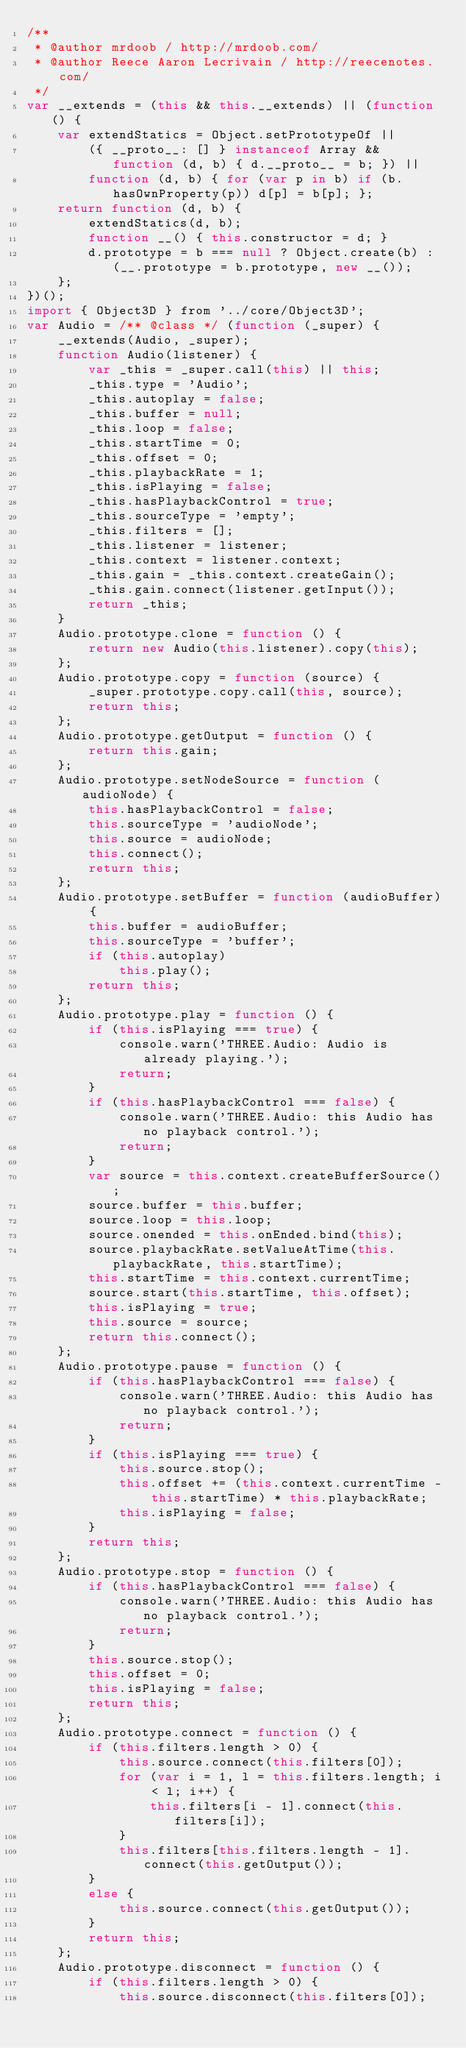Convert code to text. <code><loc_0><loc_0><loc_500><loc_500><_JavaScript_>/**
 * @author mrdoob / http://mrdoob.com/
 * @author Reece Aaron Lecrivain / http://reecenotes.com/
 */
var __extends = (this && this.__extends) || (function () {
    var extendStatics = Object.setPrototypeOf ||
        ({ __proto__: [] } instanceof Array && function (d, b) { d.__proto__ = b; }) ||
        function (d, b) { for (var p in b) if (b.hasOwnProperty(p)) d[p] = b[p]; };
    return function (d, b) {
        extendStatics(d, b);
        function __() { this.constructor = d; }
        d.prototype = b === null ? Object.create(b) : (__.prototype = b.prototype, new __());
    };
})();
import { Object3D } from '../core/Object3D';
var Audio = /** @class */ (function (_super) {
    __extends(Audio, _super);
    function Audio(listener) {
        var _this = _super.call(this) || this;
        _this.type = 'Audio';
        _this.autoplay = false;
        _this.buffer = null;
        _this.loop = false;
        _this.startTime = 0;
        _this.offset = 0;
        _this.playbackRate = 1;
        _this.isPlaying = false;
        _this.hasPlaybackControl = true;
        _this.sourceType = 'empty';
        _this.filters = [];
        _this.listener = listener;
        _this.context = listener.context;
        _this.gain = _this.context.createGain();
        _this.gain.connect(listener.getInput());
        return _this;
    }
    Audio.prototype.clone = function () {
        return new Audio(this.listener).copy(this);
    };
    Audio.prototype.copy = function (source) {
        _super.prototype.copy.call(this, source);
        return this;
    };
    Audio.prototype.getOutput = function () {
        return this.gain;
    };
    Audio.prototype.setNodeSource = function (audioNode) {
        this.hasPlaybackControl = false;
        this.sourceType = 'audioNode';
        this.source = audioNode;
        this.connect();
        return this;
    };
    Audio.prototype.setBuffer = function (audioBuffer) {
        this.buffer = audioBuffer;
        this.sourceType = 'buffer';
        if (this.autoplay)
            this.play();
        return this;
    };
    Audio.prototype.play = function () {
        if (this.isPlaying === true) {
            console.warn('THREE.Audio: Audio is already playing.');
            return;
        }
        if (this.hasPlaybackControl === false) {
            console.warn('THREE.Audio: this Audio has no playback control.');
            return;
        }
        var source = this.context.createBufferSource();
        source.buffer = this.buffer;
        source.loop = this.loop;
        source.onended = this.onEnded.bind(this);
        source.playbackRate.setValueAtTime(this.playbackRate, this.startTime);
        this.startTime = this.context.currentTime;
        source.start(this.startTime, this.offset);
        this.isPlaying = true;
        this.source = source;
        return this.connect();
    };
    Audio.prototype.pause = function () {
        if (this.hasPlaybackControl === false) {
            console.warn('THREE.Audio: this Audio has no playback control.');
            return;
        }
        if (this.isPlaying === true) {
            this.source.stop();
            this.offset += (this.context.currentTime - this.startTime) * this.playbackRate;
            this.isPlaying = false;
        }
        return this;
    };
    Audio.prototype.stop = function () {
        if (this.hasPlaybackControl === false) {
            console.warn('THREE.Audio: this Audio has no playback control.');
            return;
        }
        this.source.stop();
        this.offset = 0;
        this.isPlaying = false;
        return this;
    };
    Audio.prototype.connect = function () {
        if (this.filters.length > 0) {
            this.source.connect(this.filters[0]);
            for (var i = 1, l = this.filters.length; i < l; i++) {
                this.filters[i - 1].connect(this.filters[i]);
            }
            this.filters[this.filters.length - 1].connect(this.getOutput());
        }
        else {
            this.source.connect(this.getOutput());
        }
        return this;
    };
    Audio.prototype.disconnect = function () {
        if (this.filters.length > 0) {
            this.source.disconnect(this.filters[0]);</code> 